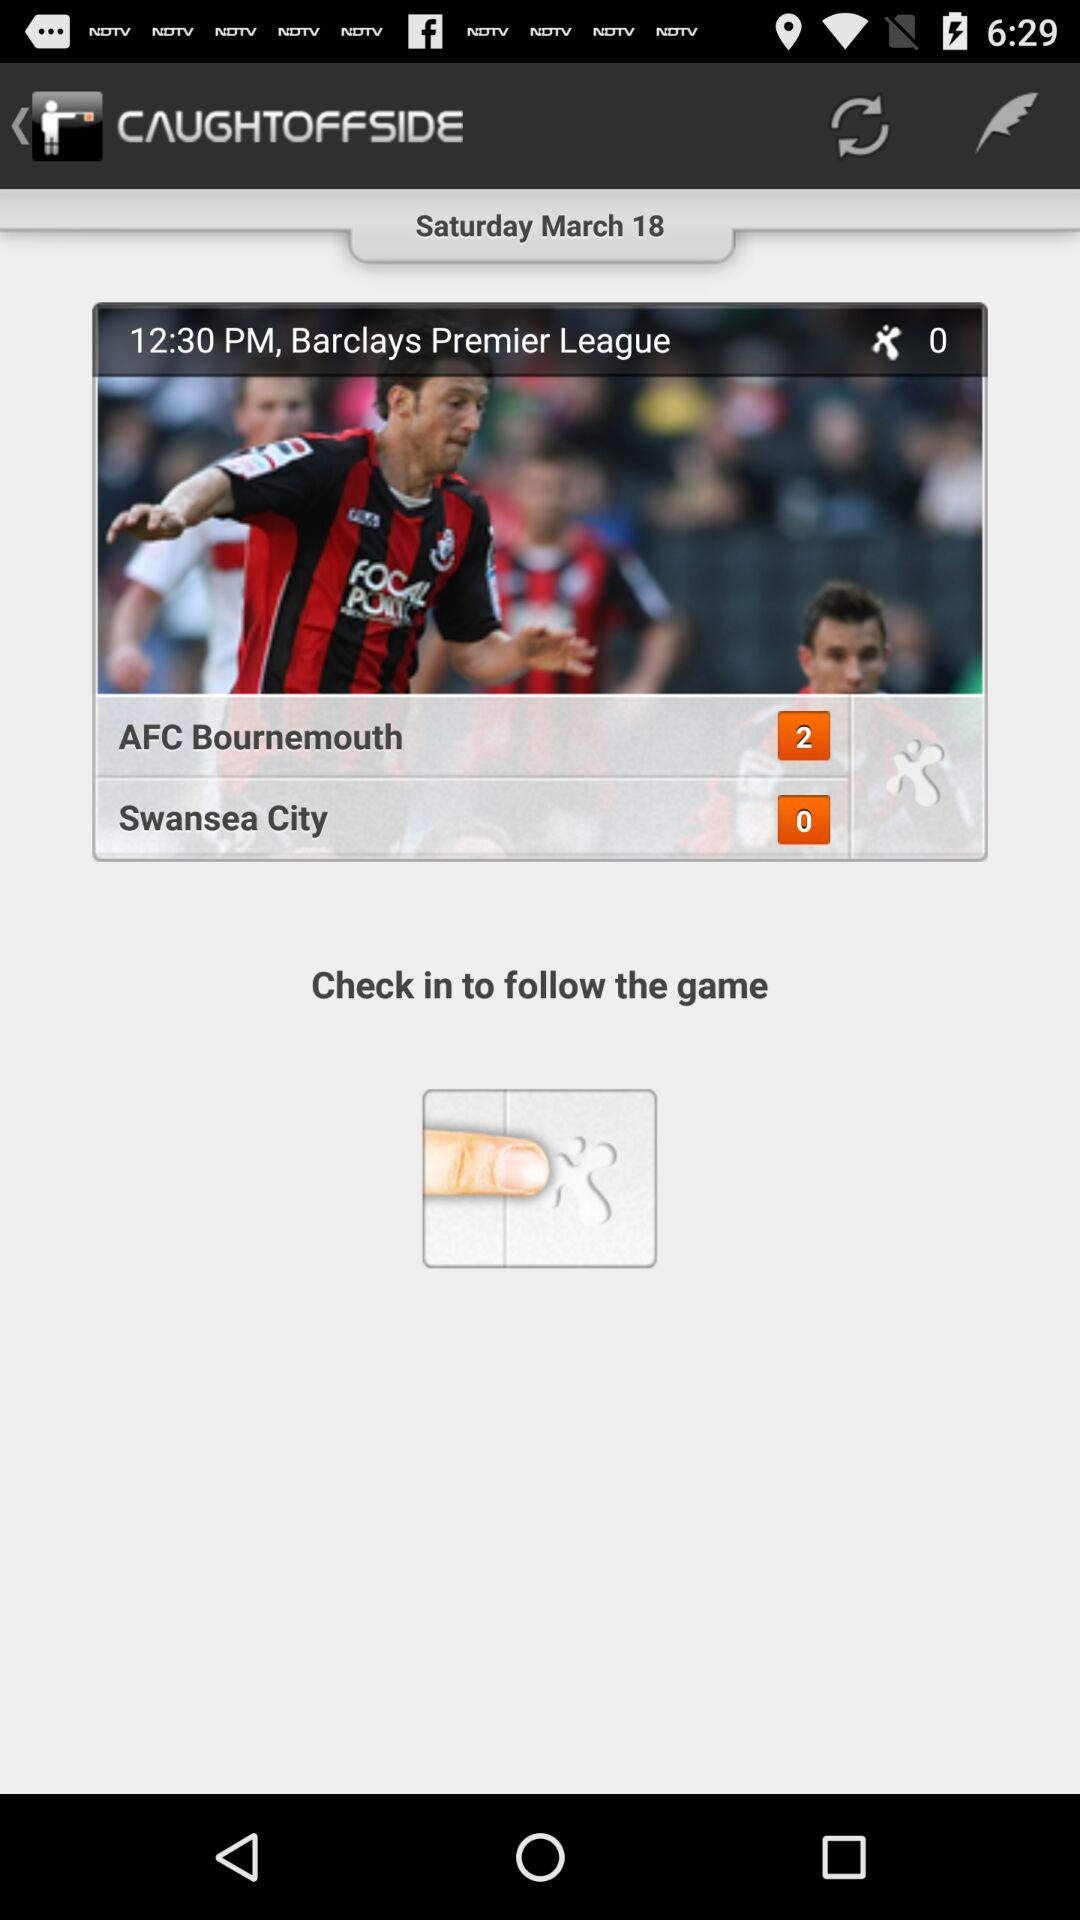How many more goals does AFC Bournemouth have than Swansea City?
Answer the question using a single word or phrase. 2 